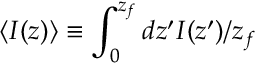<formula> <loc_0><loc_0><loc_500><loc_500>\langle I ( z ) \rangle \equiv \int _ { 0 } ^ { z _ { f } } d z ^ { \prime } I ( z ^ { \prime } ) / z _ { f }</formula> 